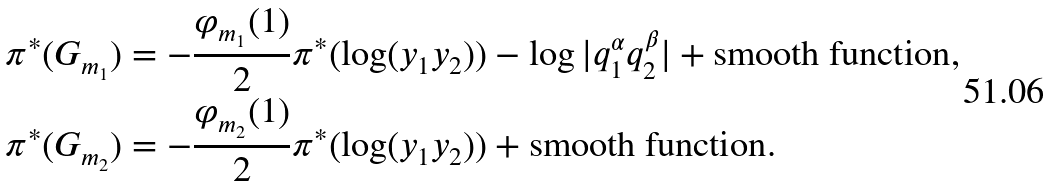<formula> <loc_0><loc_0><loc_500><loc_500>\pi ^ { * } ( G _ { m _ { 1 } } ) & = - \frac { \varphi _ { m _ { 1 } } ( 1 ) } { 2 } \pi ^ { * } ( \log ( y _ { 1 } y _ { 2 } ) ) - \log | q _ { 1 } ^ { \alpha } q _ { 2 } ^ { \beta } | + \text {smooth function} , \\ \pi ^ { * } ( G _ { m _ { 2 } } ) & = - \frac { \varphi _ { m _ { 2 } } ( 1 ) } { 2 } \pi ^ { * } ( \log ( y _ { 1 } y _ { 2 } ) ) + \text {smooth function} .</formula> 